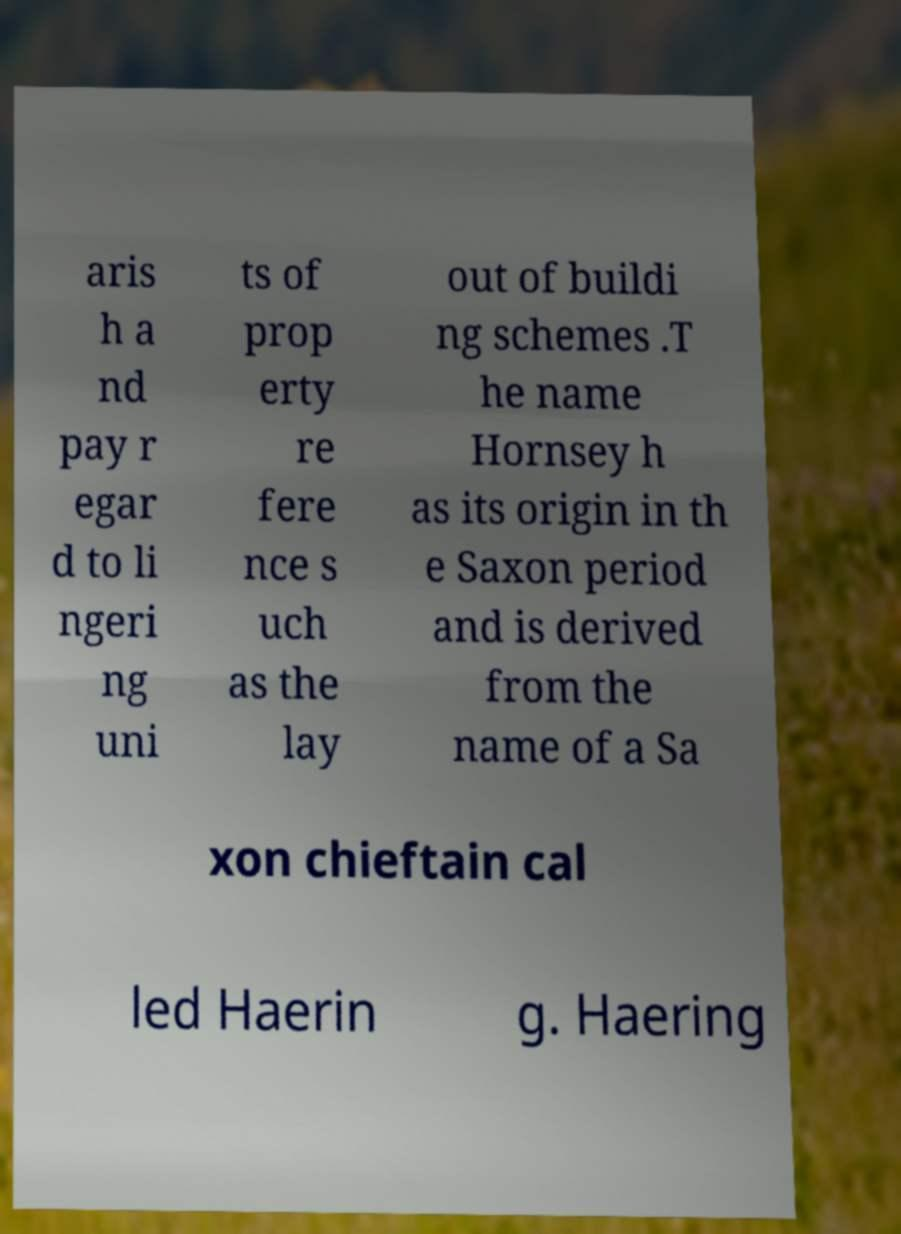Can you read and provide the text displayed in the image?This photo seems to have some interesting text. Can you extract and type it out for me? aris h a nd pay r egar d to li ngeri ng uni ts of prop erty re fere nce s uch as the lay out of buildi ng schemes .T he name Hornsey h as its origin in th e Saxon period and is derived from the name of a Sa xon chieftain cal led Haerin g. Haering 